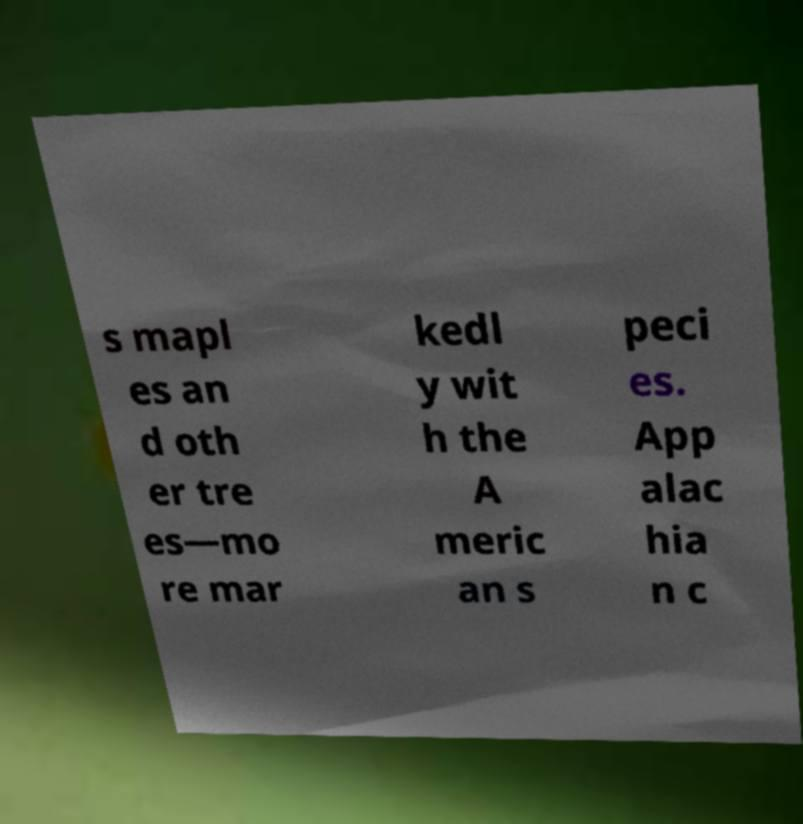Could you extract and type out the text from this image? s mapl es an d oth er tre es—mo re mar kedl y wit h the A meric an s peci es. App alac hia n c 